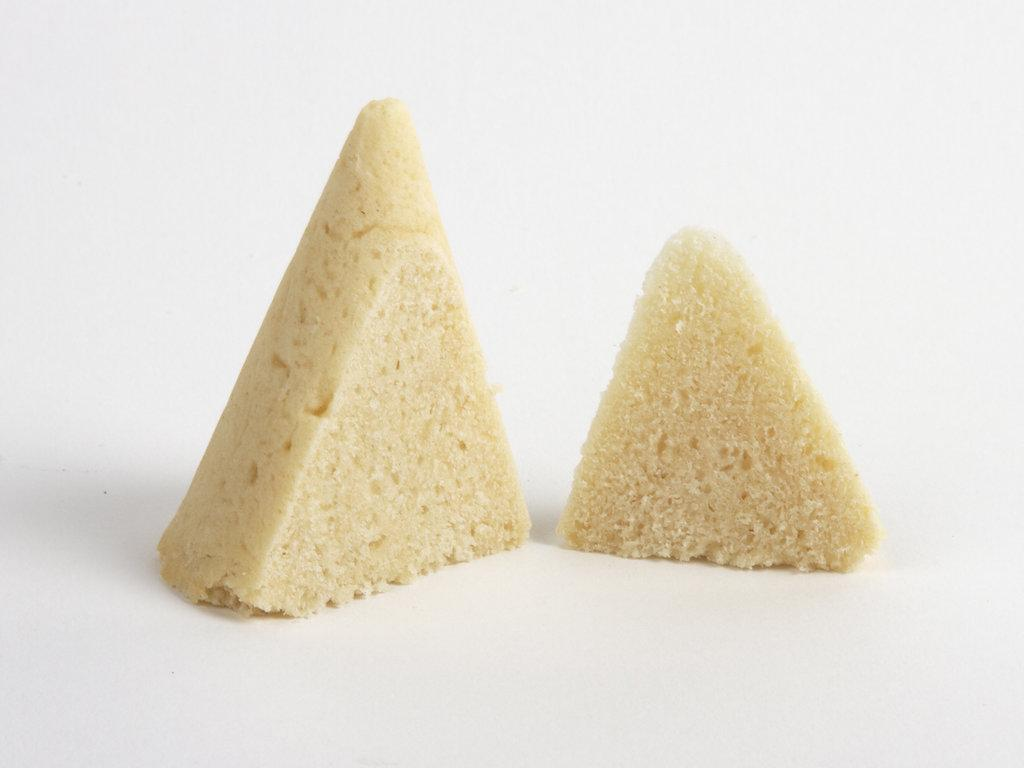How many pieces of cake are visible in the image? There are two pieces of cake in the image. What is the color of the surface the cake is on? The surface the cake is on is white. What stage of development is the cake in the image? The provided facts do not mention any development stages of the cake, so it is not possible to answer this question. 